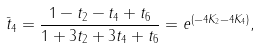Convert formula to latex. <formula><loc_0><loc_0><loc_500><loc_500>\bar { t } _ { 4 } = \frac { 1 - t _ { 2 } - t _ { 4 } + t _ { 6 } } { 1 + 3 t _ { 2 } + 3 t _ { 4 } + t _ { 6 } } = e ^ { ( - 4 K _ { 2 } - 4 K _ { 4 } ) } ,</formula> 